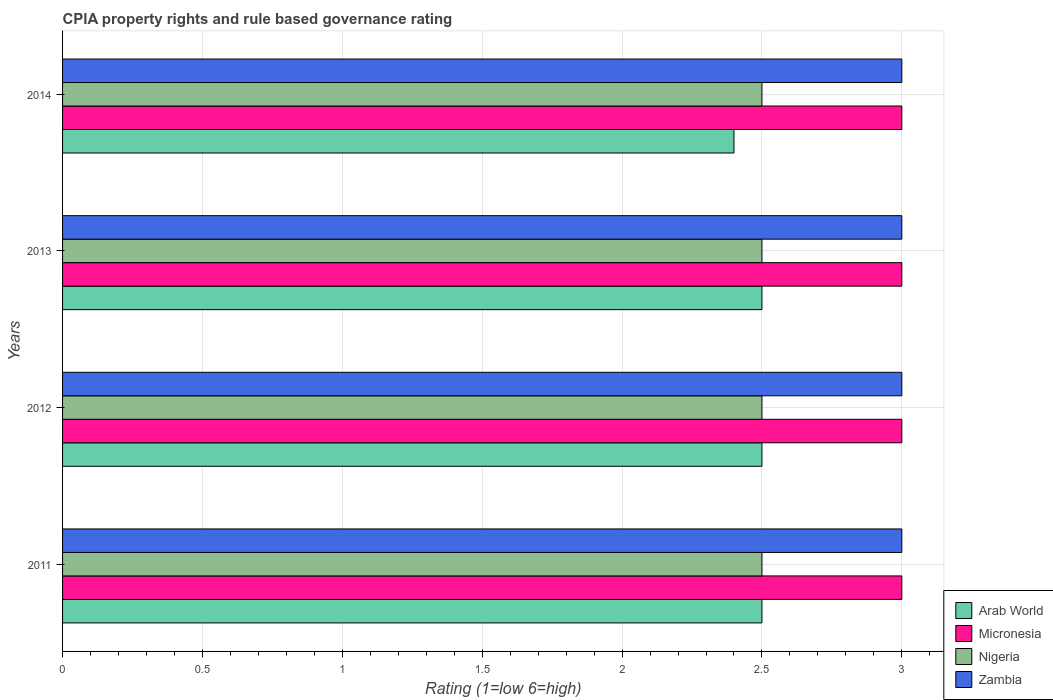How many different coloured bars are there?
Make the answer very short. 4. How many groups of bars are there?
Offer a terse response. 4. Are the number of bars per tick equal to the number of legend labels?
Your answer should be compact. Yes. Are the number of bars on each tick of the Y-axis equal?
Your answer should be very brief. Yes. In how many cases, is the number of bars for a given year not equal to the number of legend labels?
Your response must be concise. 0. Across all years, what is the maximum CPIA rating in Zambia?
Provide a succinct answer. 3. Across all years, what is the minimum CPIA rating in Micronesia?
Keep it short and to the point. 3. What is the total CPIA rating in Zambia in the graph?
Offer a terse response. 12. What is the difference between the CPIA rating in Zambia in 2012 and that in 2013?
Offer a very short reply. 0. What is the difference between the CPIA rating in Arab World in 2014 and the CPIA rating in Zambia in 2012?
Give a very brief answer. -0.6. What is the ratio of the CPIA rating in Arab World in 2011 to that in 2013?
Your response must be concise. 1. Is the difference between the CPIA rating in Nigeria in 2013 and 2014 greater than the difference between the CPIA rating in Zambia in 2013 and 2014?
Offer a terse response. No. What is the difference between the highest and the lowest CPIA rating in Arab World?
Provide a succinct answer. 0.1. In how many years, is the CPIA rating in Nigeria greater than the average CPIA rating in Nigeria taken over all years?
Your response must be concise. 0. Is it the case that in every year, the sum of the CPIA rating in Micronesia and CPIA rating in Zambia is greater than the sum of CPIA rating in Arab World and CPIA rating in Nigeria?
Your response must be concise. No. What does the 3rd bar from the top in 2011 represents?
Keep it short and to the point. Micronesia. What does the 2nd bar from the bottom in 2013 represents?
Your answer should be compact. Micronesia. Is it the case that in every year, the sum of the CPIA rating in Nigeria and CPIA rating in Arab World is greater than the CPIA rating in Micronesia?
Provide a succinct answer. Yes. How many bars are there?
Keep it short and to the point. 16. How many years are there in the graph?
Keep it short and to the point. 4. Are the values on the major ticks of X-axis written in scientific E-notation?
Give a very brief answer. No. Does the graph contain any zero values?
Give a very brief answer. No. Does the graph contain grids?
Keep it short and to the point. Yes. Where does the legend appear in the graph?
Keep it short and to the point. Bottom right. What is the title of the graph?
Ensure brevity in your answer.  CPIA property rights and rule based governance rating. What is the Rating (1=low 6=high) of Nigeria in 2011?
Provide a short and direct response. 2.5. What is the Rating (1=low 6=high) of Arab World in 2012?
Ensure brevity in your answer.  2.5. What is the Rating (1=low 6=high) of Nigeria in 2012?
Provide a succinct answer. 2.5. What is the Rating (1=low 6=high) of Zambia in 2012?
Provide a succinct answer. 3. What is the Rating (1=low 6=high) in Nigeria in 2013?
Your answer should be very brief. 2.5. What is the Rating (1=low 6=high) in Zambia in 2013?
Your answer should be very brief. 3. What is the Rating (1=low 6=high) of Micronesia in 2014?
Make the answer very short. 3. What is the Rating (1=low 6=high) in Zambia in 2014?
Ensure brevity in your answer.  3. Across all years, what is the maximum Rating (1=low 6=high) in Nigeria?
Your answer should be very brief. 2.5. Across all years, what is the minimum Rating (1=low 6=high) of Arab World?
Your response must be concise. 2.4. Across all years, what is the minimum Rating (1=low 6=high) in Micronesia?
Your answer should be compact. 3. Across all years, what is the minimum Rating (1=low 6=high) of Nigeria?
Offer a terse response. 2.5. Across all years, what is the minimum Rating (1=low 6=high) in Zambia?
Your answer should be very brief. 3. What is the total Rating (1=low 6=high) of Arab World in the graph?
Give a very brief answer. 9.9. What is the difference between the Rating (1=low 6=high) in Arab World in 2011 and that in 2012?
Offer a terse response. 0. What is the difference between the Rating (1=low 6=high) of Nigeria in 2011 and that in 2012?
Offer a terse response. 0. What is the difference between the Rating (1=low 6=high) in Nigeria in 2011 and that in 2013?
Offer a terse response. 0. What is the difference between the Rating (1=low 6=high) in Nigeria in 2011 and that in 2014?
Offer a terse response. 0. What is the difference between the Rating (1=low 6=high) of Zambia in 2011 and that in 2014?
Offer a very short reply. 0. What is the difference between the Rating (1=low 6=high) in Micronesia in 2012 and that in 2013?
Your answer should be very brief. 0. What is the difference between the Rating (1=low 6=high) of Arab World in 2012 and that in 2014?
Give a very brief answer. 0.1. What is the difference between the Rating (1=low 6=high) of Micronesia in 2012 and that in 2014?
Give a very brief answer. 0. What is the difference between the Rating (1=low 6=high) in Nigeria in 2012 and that in 2014?
Keep it short and to the point. 0. What is the difference between the Rating (1=low 6=high) of Arab World in 2013 and that in 2014?
Your answer should be very brief. 0.1. What is the difference between the Rating (1=low 6=high) of Zambia in 2013 and that in 2014?
Your response must be concise. 0. What is the difference between the Rating (1=low 6=high) of Arab World in 2011 and the Rating (1=low 6=high) of Nigeria in 2012?
Your answer should be very brief. 0. What is the difference between the Rating (1=low 6=high) in Arab World in 2011 and the Rating (1=low 6=high) in Zambia in 2012?
Give a very brief answer. -0.5. What is the difference between the Rating (1=low 6=high) in Micronesia in 2011 and the Rating (1=low 6=high) in Zambia in 2012?
Offer a terse response. 0. What is the difference between the Rating (1=low 6=high) of Nigeria in 2011 and the Rating (1=low 6=high) of Zambia in 2012?
Give a very brief answer. -0.5. What is the difference between the Rating (1=low 6=high) of Micronesia in 2011 and the Rating (1=low 6=high) of Zambia in 2013?
Offer a very short reply. 0. What is the difference between the Rating (1=low 6=high) of Nigeria in 2011 and the Rating (1=low 6=high) of Zambia in 2013?
Your response must be concise. -0.5. What is the difference between the Rating (1=low 6=high) in Arab World in 2011 and the Rating (1=low 6=high) in Micronesia in 2014?
Offer a very short reply. -0.5. What is the difference between the Rating (1=low 6=high) in Micronesia in 2011 and the Rating (1=low 6=high) in Nigeria in 2014?
Offer a terse response. 0.5. What is the difference between the Rating (1=low 6=high) of Nigeria in 2011 and the Rating (1=low 6=high) of Zambia in 2014?
Give a very brief answer. -0.5. What is the difference between the Rating (1=low 6=high) in Arab World in 2012 and the Rating (1=low 6=high) in Micronesia in 2013?
Your response must be concise. -0.5. What is the difference between the Rating (1=low 6=high) in Micronesia in 2012 and the Rating (1=low 6=high) in Nigeria in 2013?
Offer a terse response. 0.5. What is the difference between the Rating (1=low 6=high) in Arab World in 2012 and the Rating (1=low 6=high) in Micronesia in 2014?
Keep it short and to the point. -0.5. What is the difference between the Rating (1=low 6=high) in Micronesia in 2012 and the Rating (1=low 6=high) in Nigeria in 2014?
Ensure brevity in your answer.  0.5. What is the difference between the Rating (1=low 6=high) in Micronesia in 2012 and the Rating (1=low 6=high) in Zambia in 2014?
Your answer should be compact. 0. What is the difference between the Rating (1=low 6=high) of Arab World in 2013 and the Rating (1=low 6=high) of Micronesia in 2014?
Your response must be concise. -0.5. What is the difference between the Rating (1=low 6=high) of Arab World in 2013 and the Rating (1=low 6=high) of Zambia in 2014?
Provide a succinct answer. -0.5. What is the difference between the Rating (1=low 6=high) in Micronesia in 2013 and the Rating (1=low 6=high) in Nigeria in 2014?
Make the answer very short. 0.5. What is the difference between the Rating (1=low 6=high) in Micronesia in 2013 and the Rating (1=low 6=high) in Zambia in 2014?
Make the answer very short. 0. What is the difference between the Rating (1=low 6=high) in Nigeria in 2013 and the Rating (1=low 6=high) in Zambia in 2014?
Ensure brevity in your answer.  -0.5. What is the average Rating (1=low 6=high) in Arab World per year?
Offer a very short reply. 2.48. What is the average Rating (1=low 6=high) in Micronesia per year?
Offer a very short reply. 3. In the year 2011, what is the difference between the Rating (1=low 6=high) in Arab World and Rating (1=low 6=high) in Nigeria?
Provide a succinct answer. 0. In the year 2011, what is the difference between the Rating (1=low 6=high) of Arab World and Rating (1=low 6=high) of Zambia?
Your answer should be compact. -0.5. In the year 2011, what is the difference between the Rating (1=low 6=high) in Micronesia and Rating (1=low 6=high) in Nigeria?
Provide a succinct answer. 0.5. In the year 2011, what is the difference between the Rating (1=low 6=high) of Micronesia and Rating (1=low 6=high) of Zambia?
Your answer should be compact. 0. In the year 2011, what is the difference between the Rating (1=low 6=high) in Nigeria and Rating (1=low 6=high) in Zambia?
Give a very brief answer. -0.5. In the year 2012, what is the difference between the Rating (1=low 6=high) in Arab World and Rating (1=low 6=high) in Micronesia?
Your answer should be compact. -0.5. In the year 2012, what is the difference between the Rating (1=low 6=high) in Arab World and Rating (1=low 6=high) in Nigeria?
Provide a short and direct response. 0. In the year 2012, what is the difference between the Rating (1=low 6=high) of Arab World and Rating (1=low 6=high) of Zambia?
Ensure brevity in your answer.  -0.5. In the year 2012, what is the difference between the Rating (1=low 6=high) in Micronesia and Rating (1=low 6=high) in Nigeria?
Provide a short and direct response. 0.5. In the year 2013, what is the difference between the Rating (1=low 6=high) of Arab World and Rating (1=low 6=high) of Nigeria?
Your answer should be compact. 0. In the year 2013, what is the difference between the Rating (1=low 6=high) of Arab World and Rating (1=low 6=high) of Zambia?
Give a very brief answer. -0.5. In the year 2013, what is the difference between the Rating (1=low 6=high) in Micronesia and Rating (1=low 6=high) in Nigeria?
Keep it short and to the point. 0.5. In the year 2013, what is the difference between the Rating (1=low 6=high) of Micronesia and Rating (1=low 6=high) of Zambia?
Ensure brevity in your answer.  0. In the year 2014, what is the difference between the Rating (1=low 6=high) of Micronesia and Rating (1=low 6=high) of Nigeria?
Provide a short and direct response. 0.5. In the year 2014, what is the difference between the Rating (1=low 6=high) in Nigeria and Rating (1=low 6=high) in Zambia?
Make the answer very short. -0.5. What is the ratio of the Rating (1=low 6=high) in Arab World in 2011 to that in 2012?
Your answer should be very brief. 1. What is the ratio of the Rating (1=low 6=high) of Nigeria in 2011 to that in 2012?
Keep it short and to the point. 1. What is the ratio of the Rating (1=low 6=high) in Micronesia in 2011 to that in 2013?
Your answer should be very brief. 1. What is the ratio of the Rating (1=low 6=high) of Nigeria in 2011 to that in 2013?
Provide a succinct answer. 1. What is the ratio of the Rating (1=low 6=high) of Zambia in 2011 to that in 2013?
Your answer should be very brief. 1. What is the ratio of the Rating (1=low 6=high) in Arab World in 2011 to that in 2014?
Ensure brevity in your answer.  1.04. What is the ratio of the Rating (1=low 6=high) in Micronesia in 2011 to that in 2014?
Your answer should be very brief. 1. What is the ratio of the Rating (1=low 6=high) of Nigeria in 2011 to that in 2014?
Offer a terse response. 1. What is the ratio of the Rating (1=low 6=high) of Zambia in 2011 to that in 2014?
Your answer should be compact. 1. What is the ratio of the Rating (1=low 6=high) in Arab World in 2012 to that in 2013?
Offer a terse response. 1. What is the ratio of the Rating (1=low 6=high) of Micronesia in 2012 to that in 2013?
Your answer should be compact. 1. What is the ratio of the Rating (1=low 6=high) in Nigeria in 2012 to that in 2013?
Your answer should be very brief. 1. What is the ratio of the Rating (1=low 6=high) of Zambia in 2012 to that in 2013?
Provide a short and direct response. 1. What is the ratio of the Rating (1=low 6=high) in Arab World in 2012 to that in 2014?
Make the answer very short. 1.04. What is the ratio of the Rating (1=low 6=high) in Micronesia in 2012 to that in 2014?
Give a very brief answer. 1. What is the ratio of the Rating (1=low 6=high) of Nigeria in 2012 to that in 2014?
Provide a short and direct response. 1. What is the ratio of the Rating (1=low 6=high) of Zambia in 2012 to that in 2014?
Offer a very short reply. 1. What is the ratio of the Rating (1=low 6=high) in Arab World in 2013 to that in 2014?
Your response must be concise. 1.04. What is the ratio of the Rating (1=low 6=high) of Micronesia in 2013 to that in 2014?
Provide a short and direct response. 1. What is the ratio of the Rating (1=low 6=high) in Nigeria in 2013 to that in 2014?
Your answer should be compact. 1. What is the ratio of the Rating (1=low 6=high) of Zambia in 2013 to that in 2014?
Make the answer very short. 1. What is the difference between the highest and the second highest Rating (1=low 6=high) in Arab World?
Ensure brevity in your answer.  0. What is the difference between the highest and the second highest Rating (1=low 6=high) in Nigeria?
Offer a terse response. 0. What is the difference between the highest and the lowest Rating (1=low 6=high) of Nigeria?
Provide a succinct answer. 0. What is the difference between the highest and the lowest Rating (1=low 6=high) in Zambia?
Offer a very short reply. 0. 